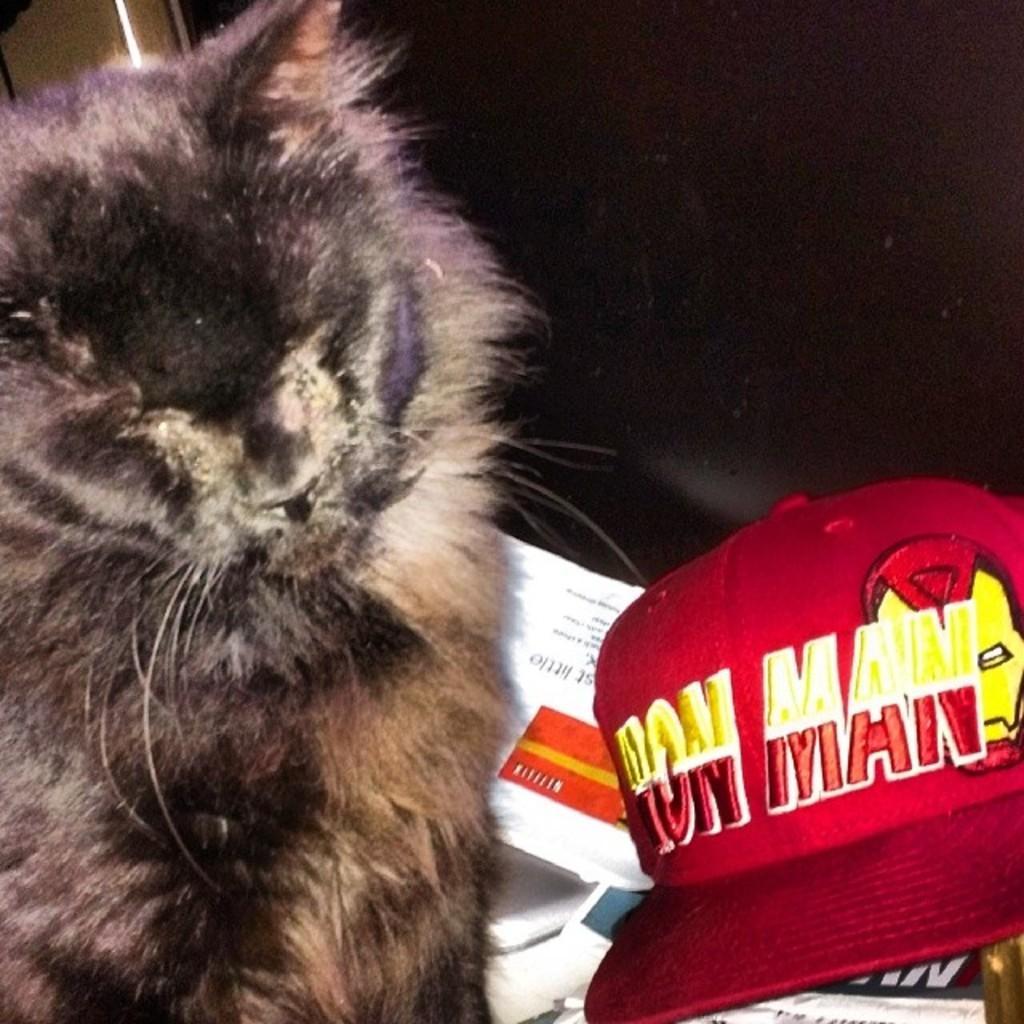Describe this image in one or two sentences. In this image, on the left side, we can see a cat. On the right side, we can see a hat which is in red color. In the background, we can also see black color, at the bottom, we can see some books and papers. 